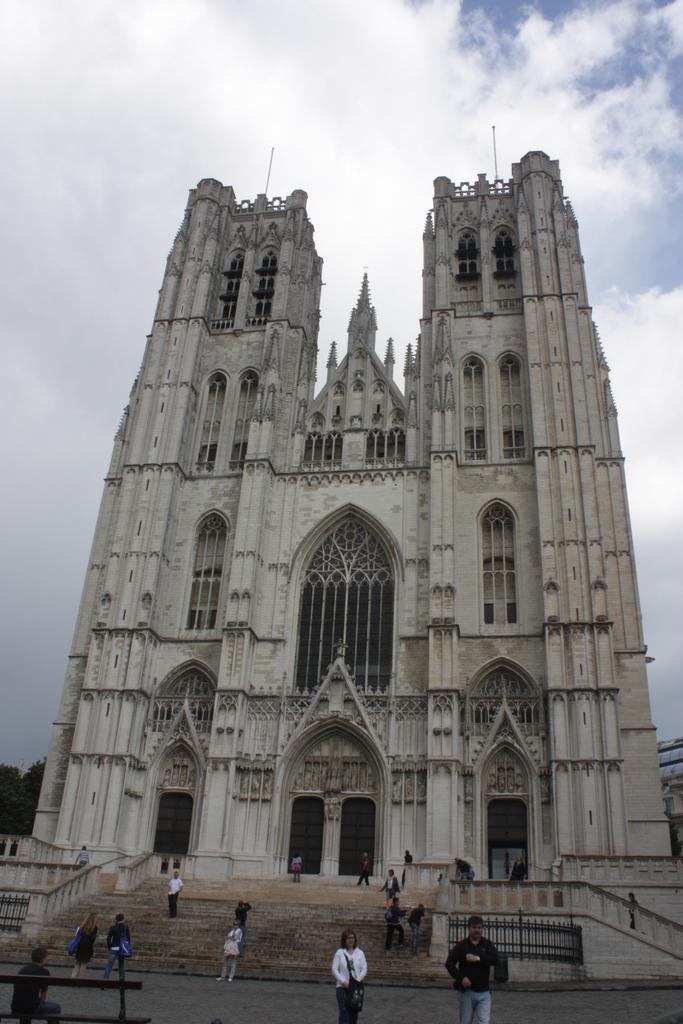How would you summarize this image in a sentence or two? In this image there is a building in the middle. In front of the building there are steps on which there are so many people. At the top there is the sky. 